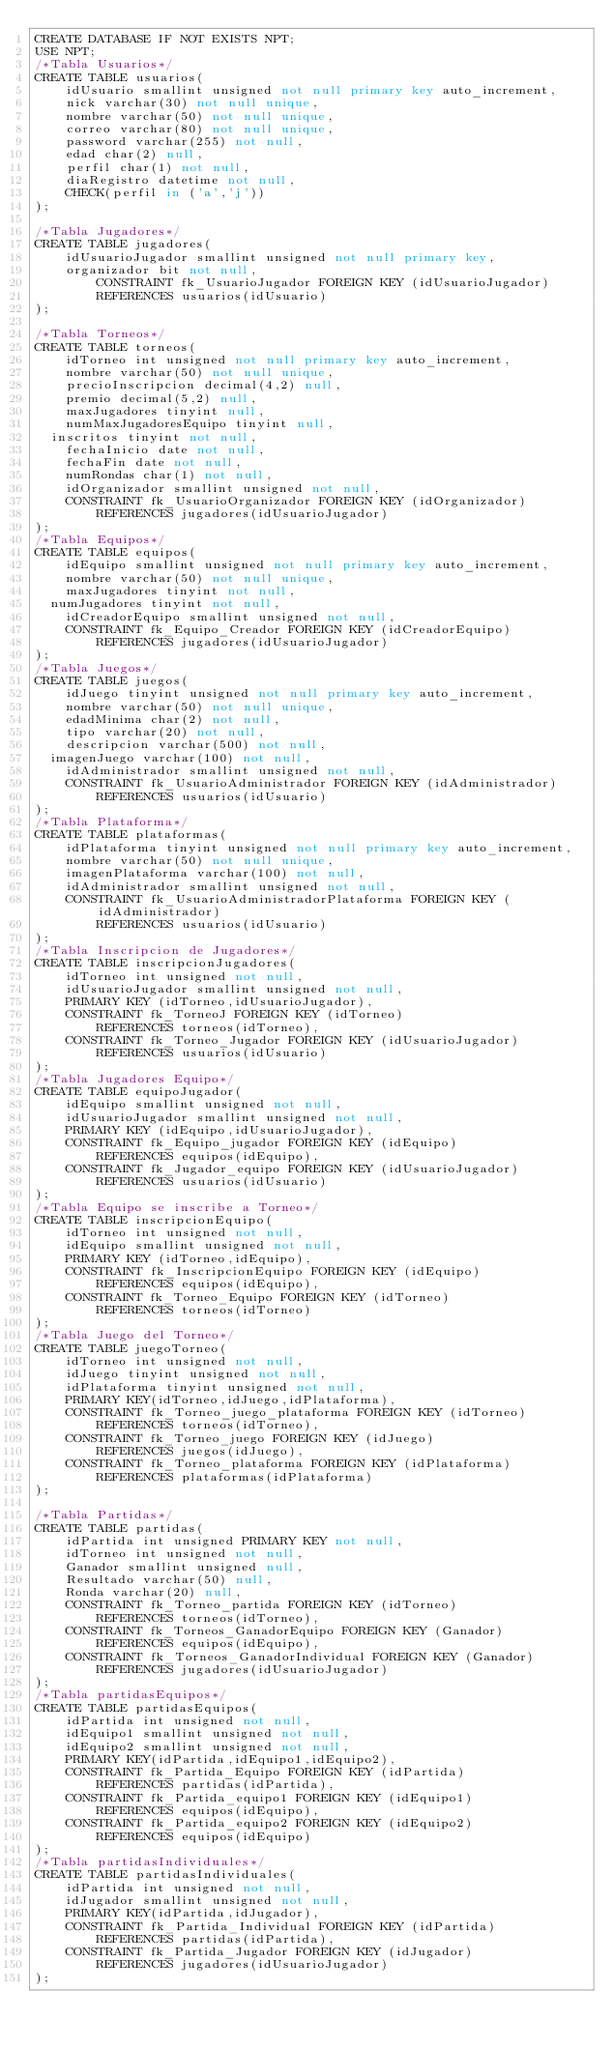<code> <loc_0><loc_0><loc_500><loc_500><_SQL_>CREATE DATABASE IF NOT EXISTS NPT;
USE NPT;
/*Tabla Usuarios*/
CREATE TABLE usuarios(
    idUsuario smallint unsigned not null primary key auto_increment,
    nick varchar(30) not null unique,
    nombre varchar(50) not null unique,
    correo varchar(80) not null unique,
    password varchar(255) not null,
    edad char(2) null,
    perfil char(1) not null,
    diaRegistro datetime not null,
    CHECK(perfil in ('a','j'))
);

/*Tabla Jugadores*/
CREATE TABLE jugadores(
    idUsuarioJugador smallint unsigned not null primary key,
    organizador bit not null,
        CONSTRAINT fk_UsuarioJugador FOREIGN KEY (idUsuarioJugador)
        REFERENCES usuarios(idUsuario)
);

/*Tabla Torneos*/
CREATE TABLE torneos(
    idTorneo int unsigned not null primary key auto_increment,
    nombre varchar(50) not null unique,
    precioInscripcion decimal(4,2) null,
    premio decimal(5,2) null,
    maxJugadores tinyint null,
    numMaxJugadoresEquipo tinyint null,
	inscritos tinyint not null,
    fechaInicio date not null,
    fechaFin date not null,
    numRondas char(1) not null,
    idOrganizador smallint unsigned not null,
    CONSTRAINT fk_UsuarioOrganizador FOREIGN KEY (idOrganizador)
        REFERENCES jugadores(idUsuarioJugador)
);
/*Tabla Equipos*/
CREATE TABLE equipos(
    idEquipo smallint unsigned not null primary key auto_increment,
    nombre varchar(50) not null unique,
    maxJugadores tinyint not null,
	numJugadores tinyint not null,
    idCreadorEquipo smallint unsigned not null,
    CONSTRAINT fk_Equipo_Creador FOREIGN KEY (idCreadorEquipo)
        REFERENCES jugadores(idUsuarioJugador)
); 
/*Tabla Juegos*/
CREATE TABLE juegos(
    idJuego tinyint unsigned not null primary key auto_increment,
    nombre varchar(50) not null unique,
    edadMinima char(2) not null,
    tipo varchar(20) not null,
    descripcion varchar(500) not null,
	imagenJuego varchar(100) not null,
    idAdministrador smallint unsigned not null,
    CONSTRAINT fk_UsuarioAdministrador FOREIGN KEY (idAdministrador)
        REFERENCES usuarios(idUsuario)
);
/*Tabla Plataforma*/
CREATE TABLE plataformas(
    idPlataforma tinyint unsigned not null primary key auto_increment,
    nombre varchar(50) not null unique,
    imagenPlataforma varchar(100) not null,
    idAdministrador smallint unsigned not null,
    CONSTRAINT fk_UsuarioAdministradorPlataforma FOREIGN KEY (idAdministrador)
        REFERENCES usuarios(idUsuario)
);
/*Tabla Inscripcion de Jugadores*/
CREATE TABLE inscripcionJugadores(
    idTorneo int unsigned not null,
    idUsuarioJugador smallint unsigned not null,
    PRIMARY KEY (idTorneo,idUsuarioJugador),
    CONSTRAINT fk_TorneoJ FOREIGN KEY (idTorneo)
        REFERENCES torneos(idTorneo),
    CONSTRAINT fk_Torneo_Jugador FOREIGN KEY (idUsuarioJugador)
        REFERENCES usuarios(idUsuario)
);
/*Tabla Jugadores Equipo*/
CREATE TABLE equipoJugador(
    idEquipo smallint unsigned not null,
    idUsuarioJugador smallint unsigned not null,
    PRIMARY KEY (idEquipo,idUsuarioJugador),
    CONSTRAINT fk_Equipo_jugador FOREIGN KEY (idEquipo)
        REFERENCES equipos(idEquipo),
    CONSTRAINT fk_Jugador_equipo FOREIGN KEY (idUsuarioJugador)
        REFERENCES usuarios(idUsuario)
);
/*Tabla Equipo se inscribe a Torneo*/
CREATE TABLE inscripcionEquipo(
    idTorneo int unsigned not null,
    idEquipo smallint unsigned not null,
    PRIMARY KEY (idTorneo,idEquipo),
    CONSTRAINT fk_InscripcionEquipo FOREIGN KEY (idEquipo)
        REFERENCES equipos(idEquipo),
    CONSTRAINT fk_Torneo_Equipo FOREIGN KEY (idTorneo)
        REFERENCES torneos(idTorneo)
);
/*Tabla Juego del Torneo*/
CREATE TABLE juegoTorneo(
    idTorneo int unsigned not null,
    idJuego tinyint unsigned not null,
    idPlataforma tinyint unsigned not null,
    PRIMARY KEY(idTorneo,idJuego,idPlataforma),
    CONSTRAINT fk_Torneo_juego_plataforma FOREIGN KEY (idTorneo)
        REFERENCES torneos(idTorneo),
    CONSTRAINT fk_Torneo_juego FOREIGN KEY (idJuego)
        REFERENCES juegos(idJuego),
    CONSTRAINT fk_Torneo_plataforma FOREIGN KEY (idPlataforma)
        REFERENCES plataformas(idPlataforma)
);

/*Tabla Partidas*/
CREATE TABLE partidas(
    idPartida int unsigned PRIMARY KEY not null, 
    idTorneo int unsigned not null,
    Ganador smallint unsigned null,
    Resultado varchar(50) null,
    Ronda varchar(20) null,
    CONSTRAINT fk_Torneo_partida FOREIGN KEY (idTorneo)
        REFERENCES torneos(idTorneo),
    CONSTRAINT fk_Torneos_GanadorEquipo FOREIGN KEY (Ganador)
        REFERENCES equipos(idEquipo),
    CONSTRAINT fk_Torneos_GanadorIndividual FOREIGN KEY (Ganador)
        REFERENCES jugadores(idUsuarioJugador)
);
/*Tabla partidasEquipos*/
CREATE TABLE partidasEquipos(
    idPartida int unsigned not null,
    idEquipo1 smallint unsigned not null,
    idEquipo2 smallint unsigned not null,
    PRIMARY KEY(idPartida,idEquipo1,idEquipo2),
    CONSTRAINT fk_Partida_Equipo FOREIGN KEY (idPartida)
        REFERENCES partidas(idPartida),
    CONSTRAINT fk_Partida_equipo1 FOREIGN KEY (idEquipo1)
        REFERENCES equipos(idEquipo),
    CONSTRAINT fk_Partida_equipo2 FOREIGN KEY (idEquipo2)
        REFERENCES equipos(idEquipo)
);
/*Tabla partidasIndividuales*/
CREATE TABLE partidasIndividuales(
    idPartida int unsigned not null,
    idJugador smallint unsigned not null,
    PRIMARY KEY(idPartida,idJugador),
    CONSTRAINT fk_Partida_Individual FOREIGN KEY (idPartida)
        REFERENCES partidas(idPartida),
    CONSTRAINT fk_Partida_Jugador FOREIGN KEY (idJugador)
        REFERENCES jugadores(idUsuarioJugador)
);</code> 